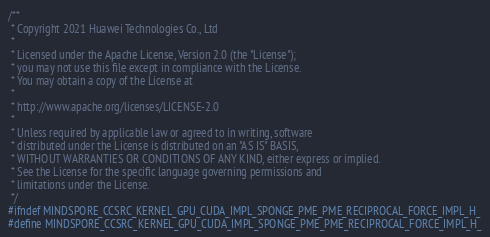<code> <loc_0><loc_0><loc_500><loc_500><_Cuda_>/**
 * Copyright 2021 Huawei Technologies Co., Ltd
 *
 * Licensed under the Apache License, Version 2.0 (the "License");
 * you may not use this file except in compliance with the License.
 * You may obtain a copy of the License at
 *
 * http://www.apache.org/licenses/LICENSE-2.0
 *
 * Unless required by applicable law or agreed to in writing, software
 * distributed under the License is distributed on an "AS IS" BASIS,
 * WITHOUT WARRANTIES OR CONDITIONS OF ANY KIND, either express or implied.
 * See the License for the specific language governing permissions and
 * limitations under the License.
 */
#ifndef MINDSPORE_CCSRC_KERNEL_GPU_CUDA_IMPL_SPONGE_PME_PME_RECIPROCAL_FORCE_IMPL_H_
#define MINDSPORE_CCSRC_KERNEL_GPU_CUDA_IMPL_SPONGE_PME_PME_RECIPROCAL_FORCE_IMPL_H_
</code> 